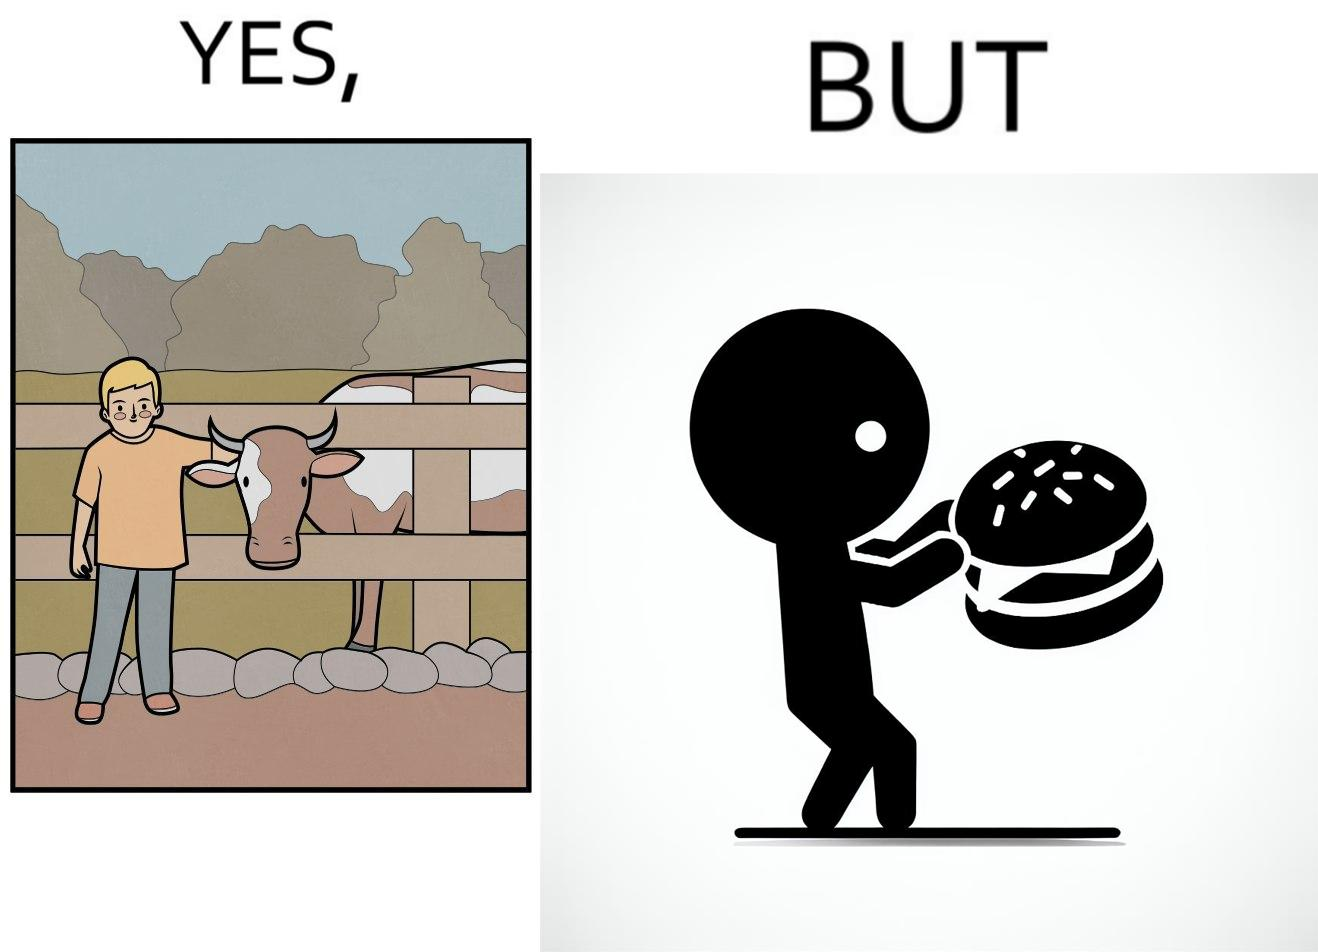Is this a satirical image? Yes, this image is satirical. 